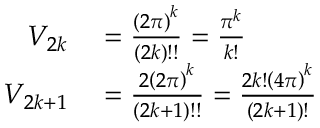Convert formula to latex. <formula><loc_0><loc_0><loc_500><loc_500>\begin{array} { r l } { V _ { 2 k } } & = { \frac { \left ( 2 \pi \right ) ^ { k } } { ( 2 k ) ! ! } } = { \frac { \pi ^ { k } } { k ! } } } \\ { V _ { 2 k + 1 } } & = { \frac { 2 \left ( 2 \pi \right ) ^ { k } } { ( 2 k + 1 ) ! ! } } = { \frac { 2 k ! \left ( 4 \pi \right ) ^ { k } } { ( 2 k + 1 ) ! } } } \end{array}</formula> 